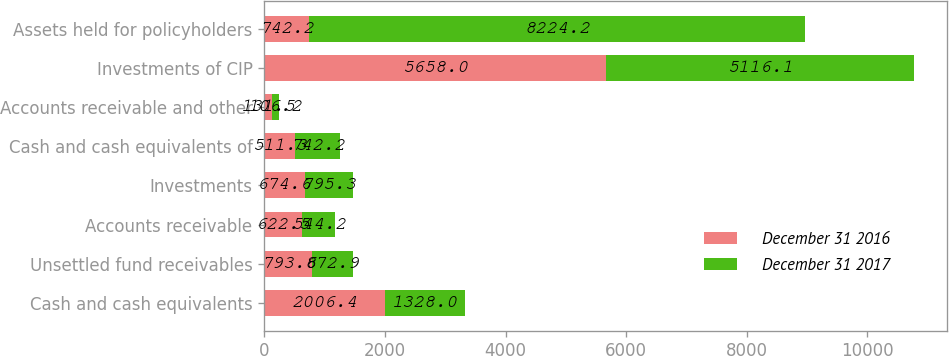<chart> <loc_0><loc_0><loc_500><loc_500><stacked_bar_chart><ecel><fcel>Cash and cash equivalents<fcel>Unsettled fund receivables<fcel>Accounts receivable<fcel>Investments<fcel>Cash and cash equivalents of<fcel>Accounts receivable and other<fcel>Investments of CIP<fcel>Assets held for policyholders<nl><fcel>December 31 2016<fcel>2006.4<fcel>793.8<fcel>622.5<fcel>674.6<fcel>511.3<fcel>131.5<fcel>5658<fcel>742.2<nl><fcel>December 31 2017<fcel>1328<fcel>672.9<fcel>544.2<fcel>795.3<fcel>742.2<fcel>106.2<fcel>5116.1<fcel>8224.2<nl></chart> 